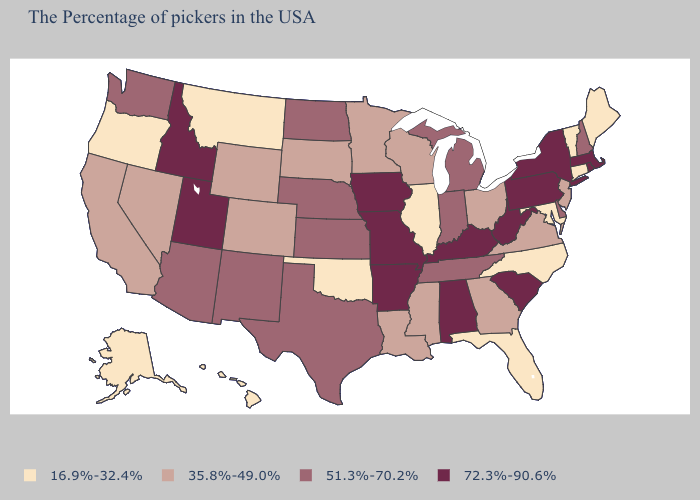Which states have the highest value in the USA?
Give a very brief answer. Massachusetts, Rhode Island, New York, Pennsylvania, South Carolina, West Virginia, Kentucky, Alabama, Missouri, Arkansas, Iowa, Utah, Idaho. Does Texas have the lowest value in the South?
Be succinct. No. What is the lowest value in the USA?
Quick response, please. 16.9%-32.4%. What is the value of Vermont?
Short answer required. 16.9%-32.4%. What is the value of South Carolina?
Quick response, please. 72.3%-90.6%. Name the states that have a value in the range 72.3%-90.6%?
Answer briefly. Massachusetts, Rhode Island, New York, Pennsylvania, South Carolina, West Virginia, Kentucky, Alabama, Missouri, Arkansas, Iowa, Utah, Idaho. Which states hav the highest value in the Northeast?
Concise answer only. Massachusetts, Rhode Island, New York, Pennsylvania. Name the states that have a value in the range 16.9%-32.4%?
Answer briefly. Maine, Vermont, Connecticut, Maryland, North Carolina, Florida, Illinois, Oklahoma, Montana, Oregon, Alaska, Hawaii. Among the states that border New York , which have the lowest value?
Give a very brief answer. Vermont, Connecticut. What is the lowest value in states that border South Dakota?
Keep it brief. 16.9%-32.4%. Name the states that have a value in the range 72.3%-90.6%?
Write a very short answer. Massachusetts, Rhode Island, New York, Pennsylvania, South Carolina, West Virginia, Kentucky, Alabama, Missouri, Arkansas, Iowa, Utah, Idaho. What is the value of Arizona?
Keep it brief. 51.3%-70.2%. Does Georgia have a lower value than California?
Give a very brief answer. No. What is the value of Arkansas?
Give a very brief answer. 72.3%-90.6%. Among the states that border West Virginia , which have the highest value?
Keep it brief. Pennsylvania, Kentucky. 